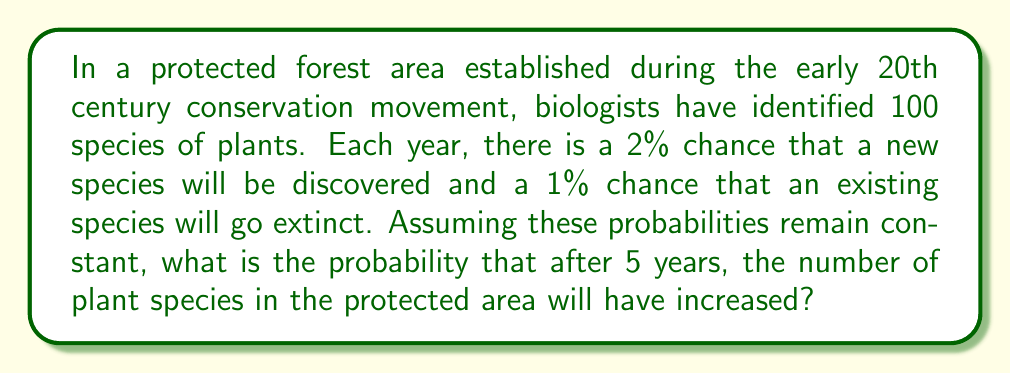What is the answer to this math problem? Let's approach this step-by-step using probability theory:

1) First, we need to calculate the probability of three possible outcomes for each year:
   a) Number of species increases: $P(increase) = 0.02 \times 0.99 = 0.0198$
   b) Number of species decreases: $P(decrease) = 0.01 \times 0.98 = 0.0098$
   c) Number of species stays the same: $P(same) = 0.99 \times 0.98 + 0.01 \times 0.02 = 0.9704$

2) Now, we need to find the probability that after 5 years, the number of species has increased. This is equivalent to finding the probability that the number of increases is greater than the number of decreases.

3) We can model this as a random walk on a number line, where each step is independent. Let $X$ be the number of steps to the right (increases) minus the number of steps to the left (decreases) after 5 years.

4) $X$ follows a binomial distribution with parameters $n=5$ and $p = P(increase) - P(decrease) = 0.0198 - 0.0098 = 0.01$

5) We want to find $P(X > 0)$. This is equal to $1 - P(X \leq 0)$

6) Using the binomial distribution formula:
   $$P(X = k) = \binom{n}{k} p^k (1-p)^{n-k}$$

7) We need to calculate:
   $$P(X > 0) = 1 - [P(X = 0) + P(X = -1) + P(X = -2) + P(X = -3) + P(X = -4) + P(X = -5)]$$

8) Calculating each term:
   $$P(X = 0) = \binom{5}{0} 0.01^0 0.99^5 = 0.9510$$
   $$P(X = -1) = \binom{5}{1} 0.01^1 0.99^4 = 0.0480$$
   $$P(X = -2) = \binom{5}{2} 0.01^2 0.99^3 = 0.0010$$
   $$P(X = -3) = \binom{5}{3} 0.01^3 0.99^2 \approx 0.0000$$
   $$P(X = -4) = \binom{5}{4} 0.01^4 0.99^1 \approx 0.0000$$
   $$P(X = -5) = \binom{5}{5} 0.01^5 0.99^0 \approx 0.0000$$

9) Summing these up:
   $$P(X \leq 0) = 0.9510 + 0.0480 + 0.0010 + 0.0000 + 0.0000 + 0.0000 = 1.0000$$

10) Therefore:
    $$P(X > 0) = 1 - P(X \leq 0) = 1 - 1.0000 = 0.0000$$
Answer: 0 